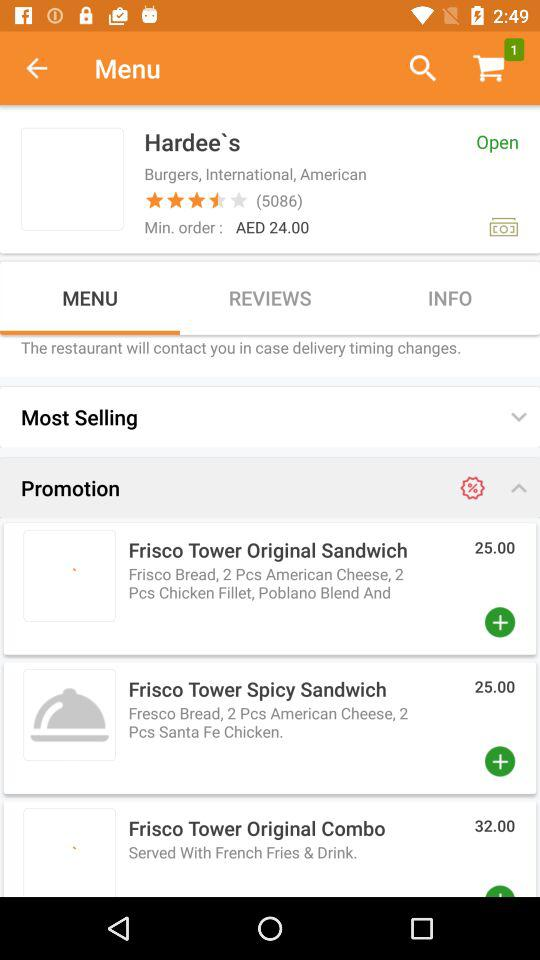How many things were added to the cart? The number of things that were added to the cart is 1. 